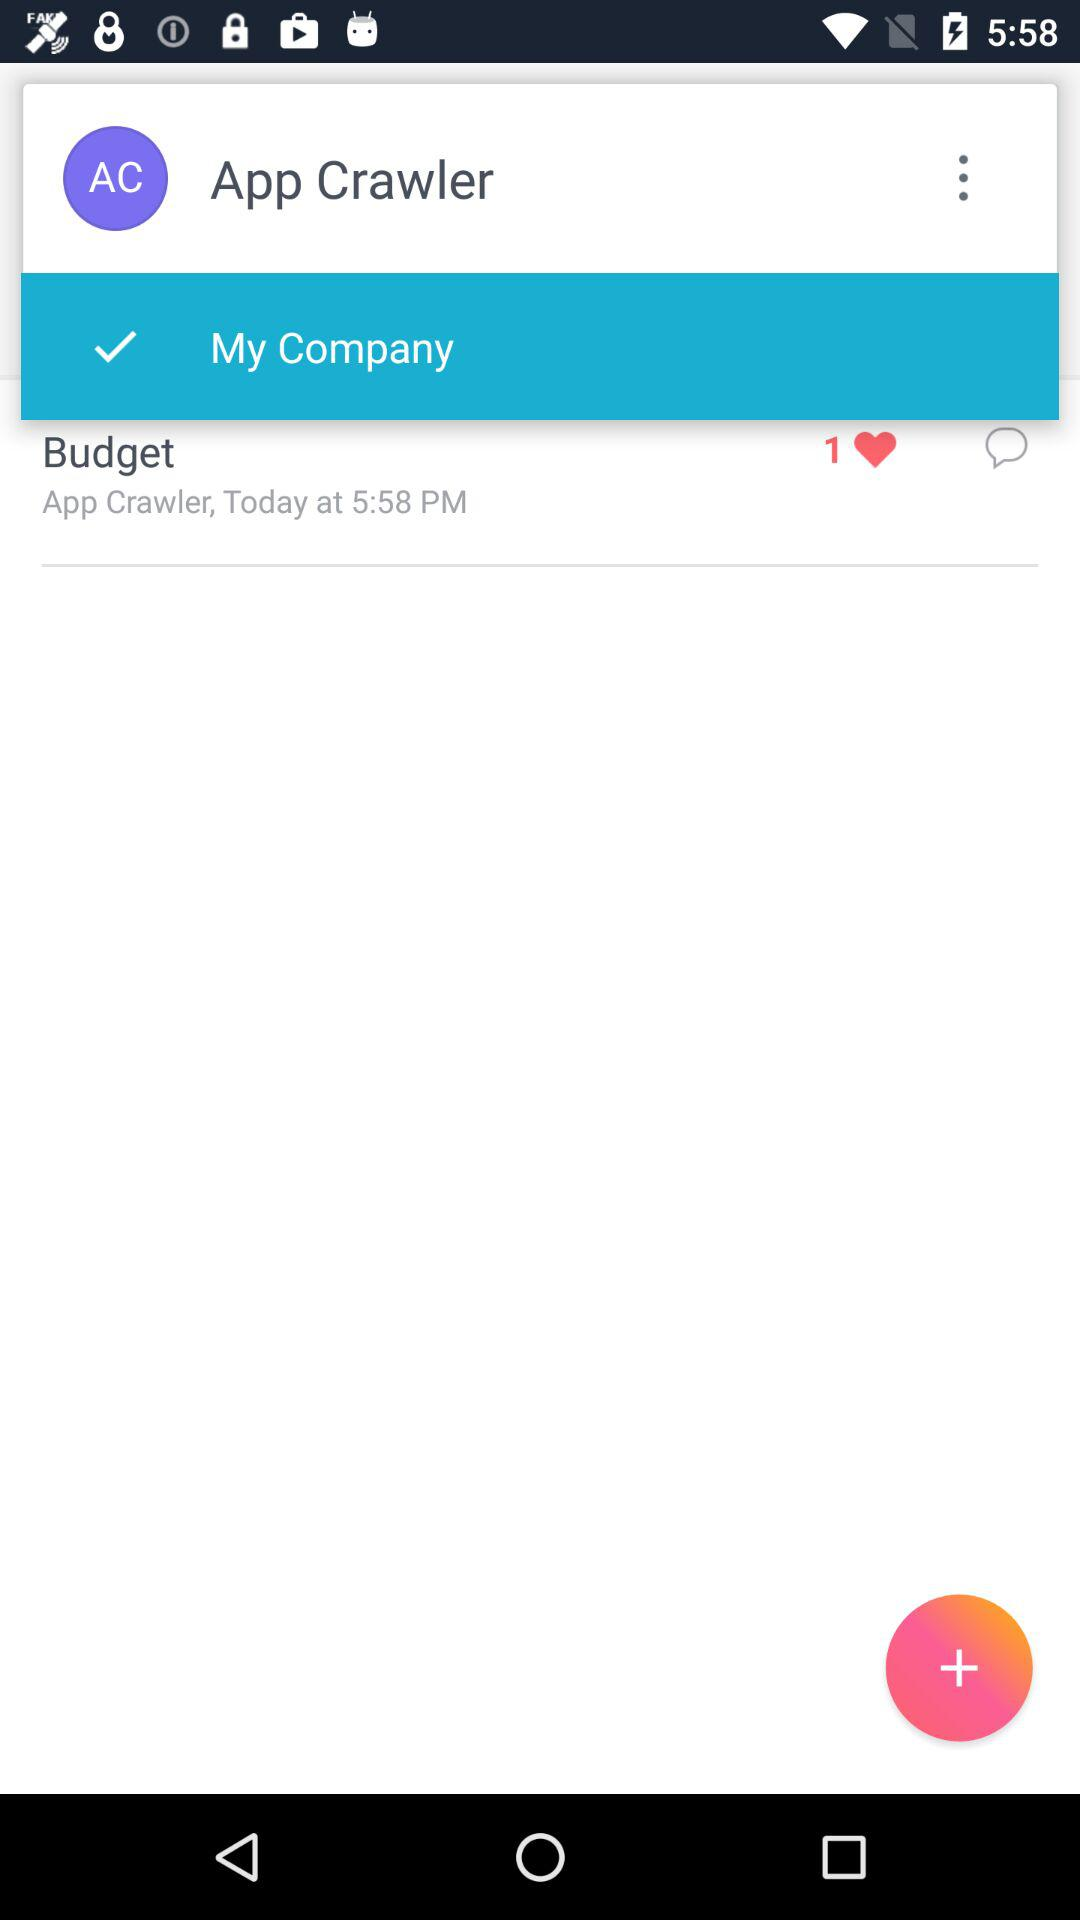How many hearts are there on the screen?
Answer the question using a single word or phrase. 1 